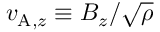<formula> <loc_0><loc_0><loc_500><loc_500>v _ { A , z } \equiv B _ { z } / \sqrt { \rho }</formula> 